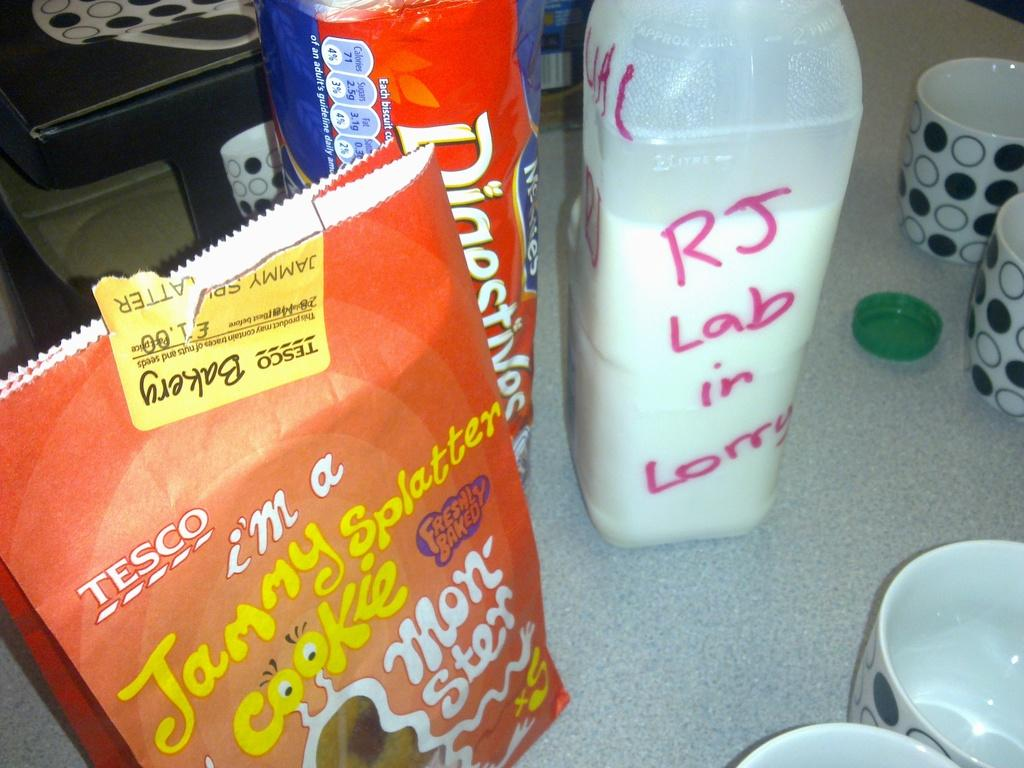Provide a one-sentence caption for the provided image. Several food items, including Jammy Splatter cookies, sit on a counter. 